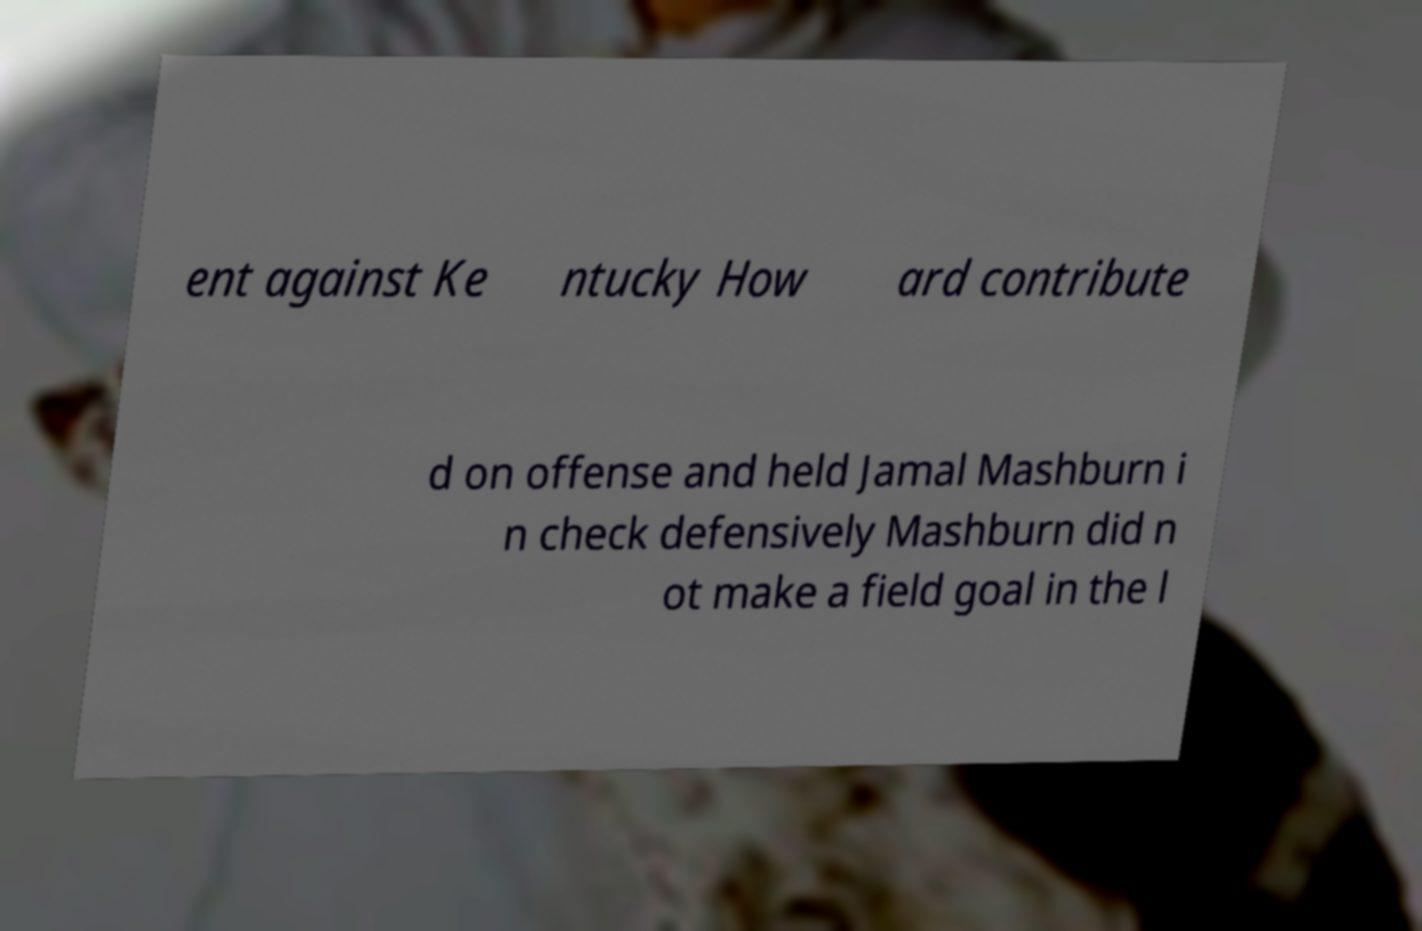I need the written content from this picture converted into text. Can you do that? ent against Ke ntucky How ard contribute d on offense and held Jamal Mashburn i n check defensively Mashburn did n ot make a field goal in the l 